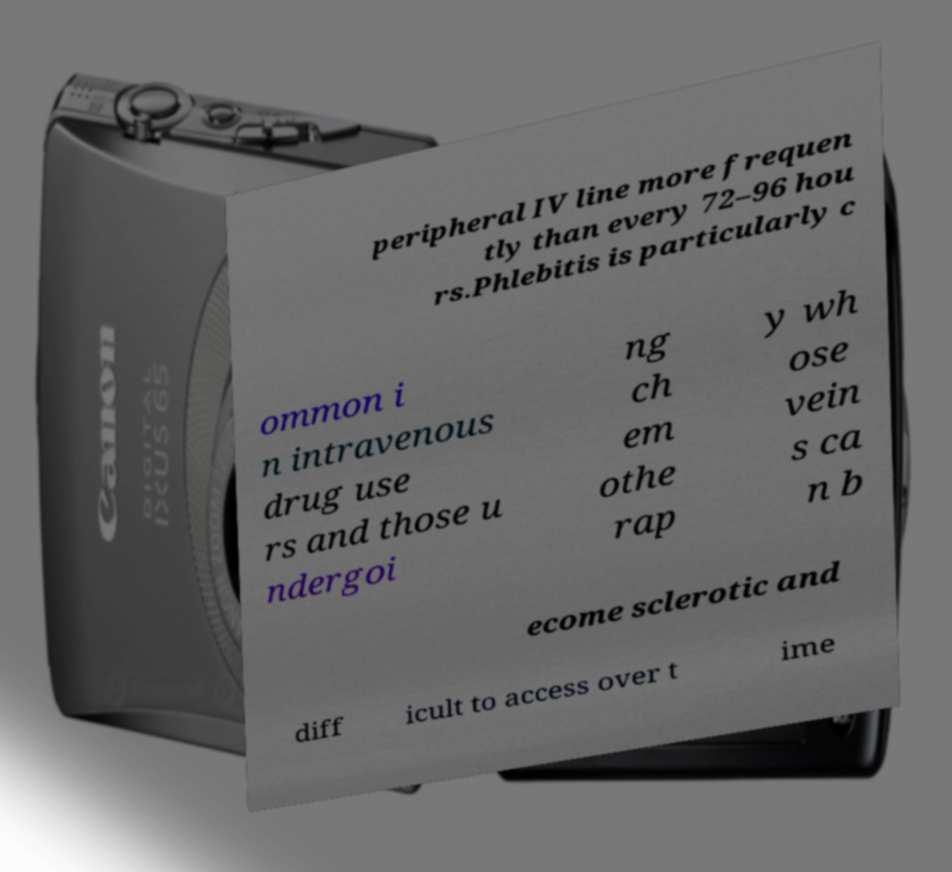Could you assist in decoding the text presented in this image and type it out clearly? peripheral IV line more frequen tly than every 72–96 hou rs.Phlebitis is particularly c ommon i n intravenous drug use rs and those u ndergoi ng ch em othe rap y wh ose vein s ca n b ecome sclerotic and diff icult to access over t ime 